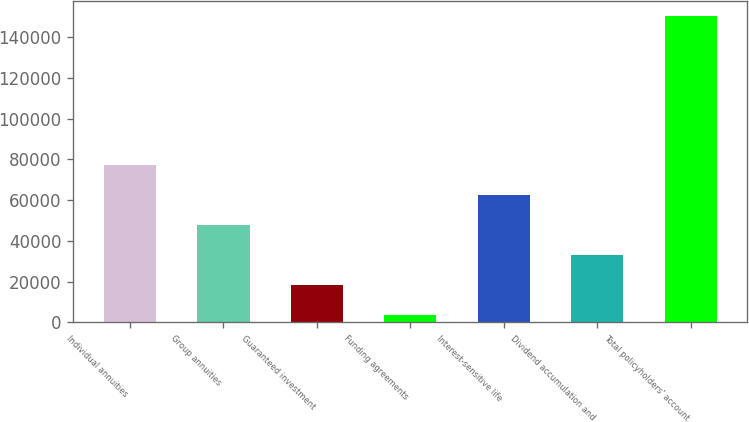Convert chart to OTSL. <chart><loc_0><loc_0><loc_500><loc_500><bar_chart><fcel>Individual annuities<fcel>Group annuities<fcel>Guaranteed investment<fcel>Funding agreements<fcel>Interest-sensitive life<fcel>Dividend accumulation and<fcel>Total policyholders' account<nl><fcel>77061.5<fcel>47750.9<fcel>18440.3<fcel>3785<fcel>62406.2<fcel>33095.6<fcel>150338<nl></chart> 